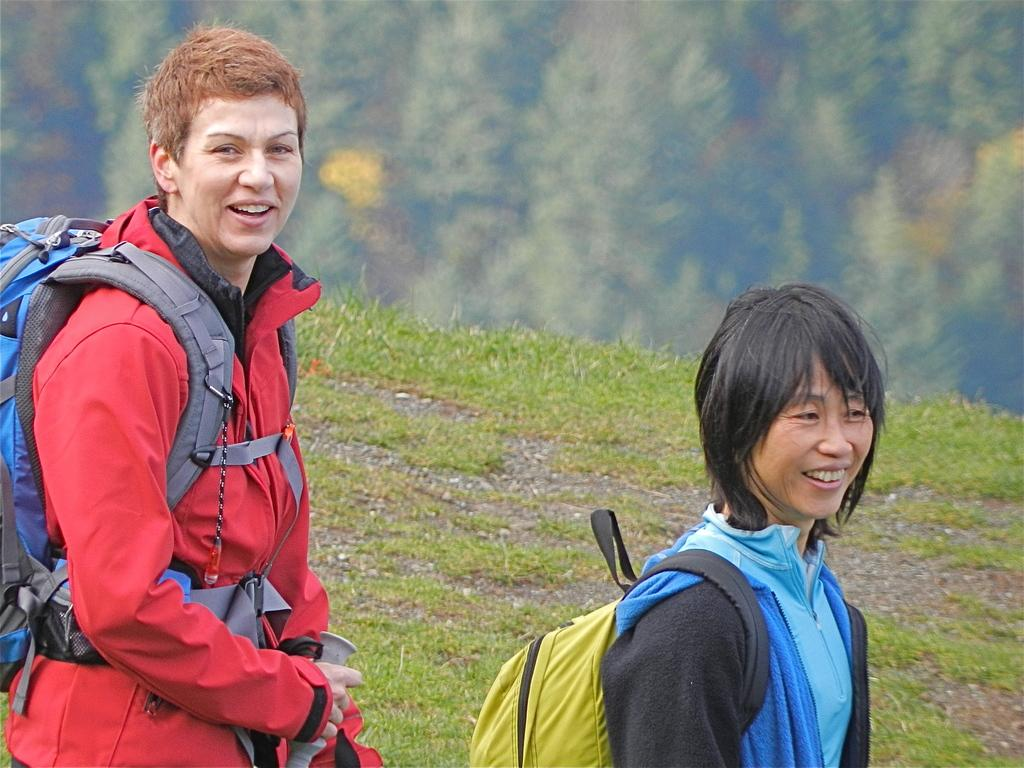How many women are in the image? There are two women in the image. What are the women holding in the image? The women are holding bags. What expression do the women have in the image? The women are smiling. What type of surface is under the women's feet in the image? There is grass on the ground in the image. How would you describe the background of the image? The background of the image is blurred. What type of drawer can be seen in the image? There is no drawer present in the image. How many parcels are visible in the image? There are no parcels visible in the image. 